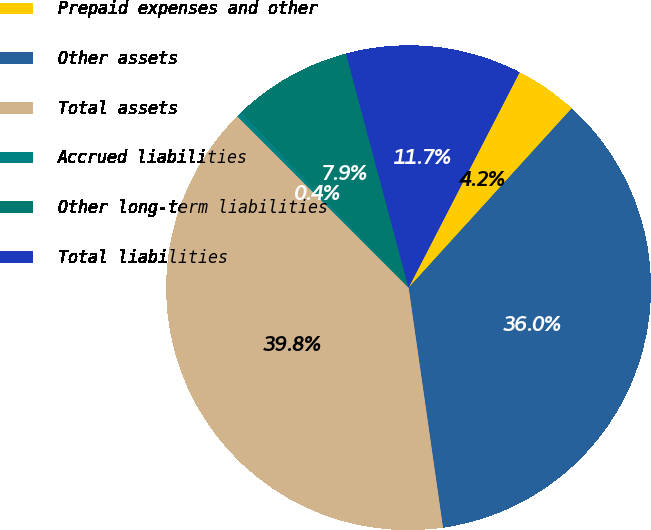Convert chart. <chart><loc_0><loc_0><loc_500><loc_500><pie_chart><fcel>Prepaid expenses and other<fcel>Other assets<fcel>Total assets<fcel>Accrued liabilities<fcel>Other long-term liabilities<fcel>Total liabilities<nl><fcel>4.17%<fcel>35.99%<fcel>39.77%<fcel>0.39%<fcel>7.95%<fcel>11.73%<nl></chart> 